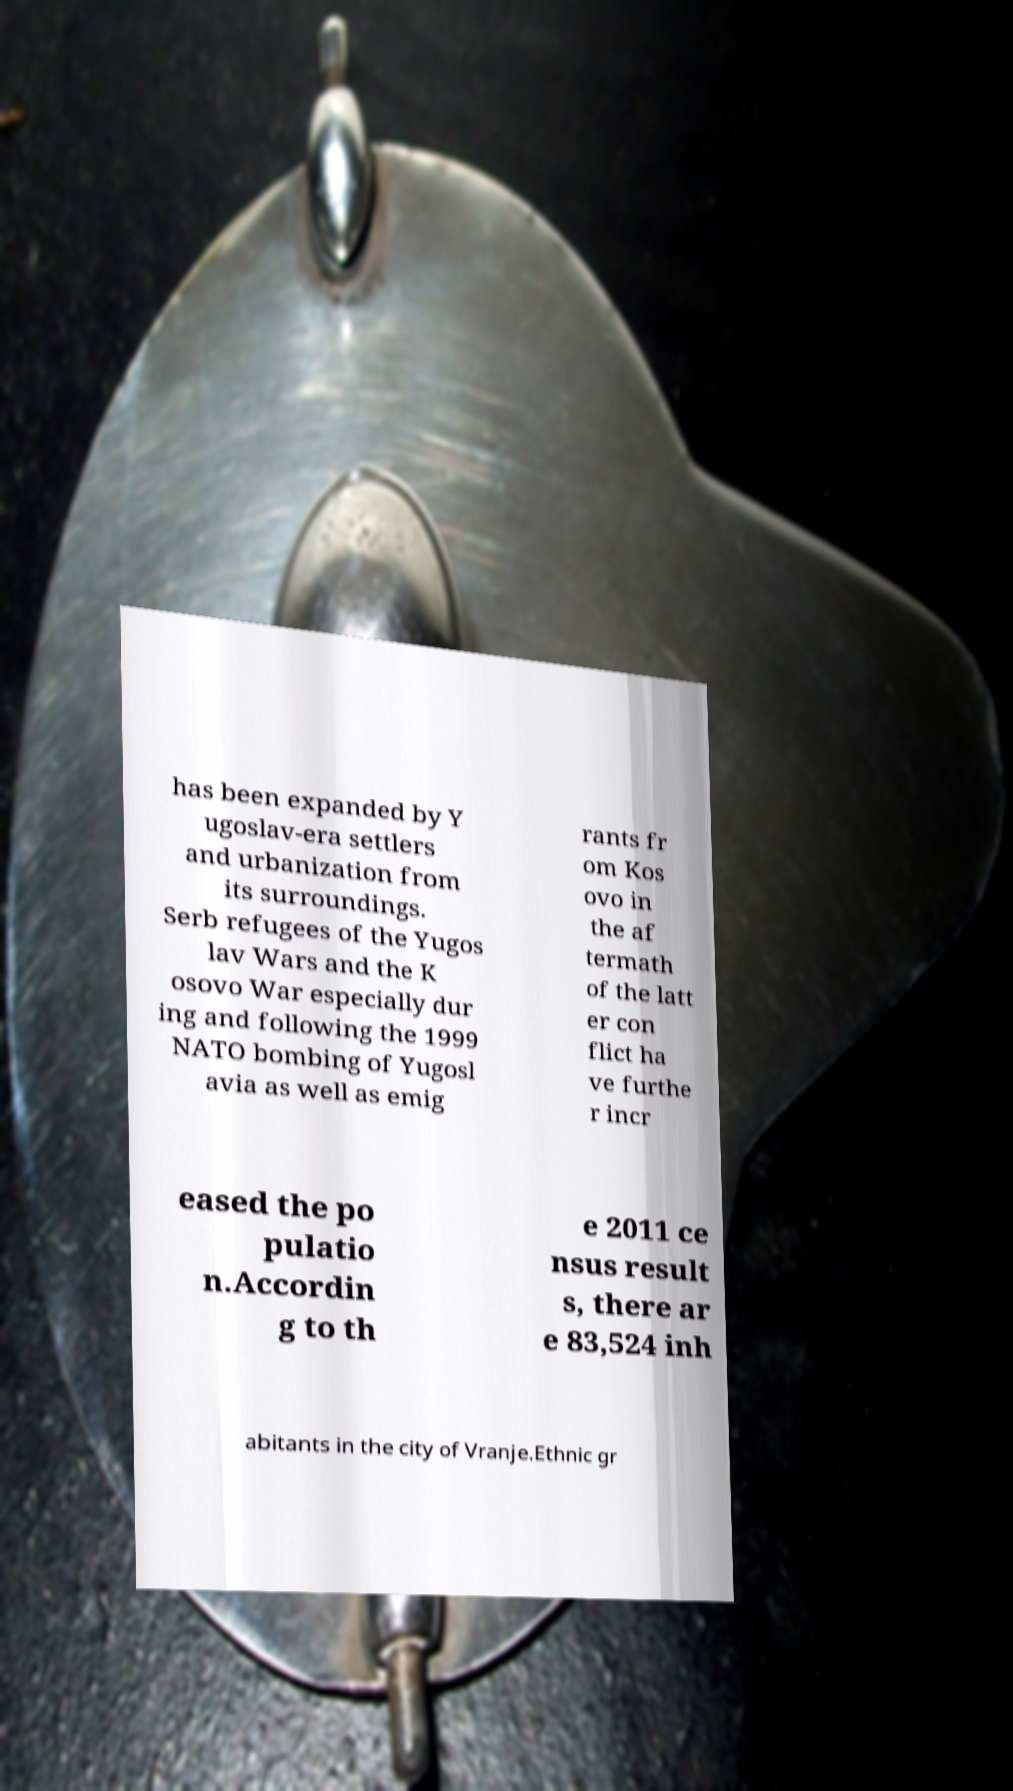What messages or text are displayed in this image? I need them in a readable, typed format. has been expanded by Y ugoslav-era settlers and urbanization from its surroundings. Serb refugees of the Yugos lav Wars and the K osovo War especially dur ing and following the 1999 NATO bombing of Yugosl avia as well as emig rants fr om Kos ovo in the af termath of the latt er con flict ha ve furthe r incr eased the po pulatio n.Accordin g to th e 2011 ce nsus result s, there ar e 83,524 inh abitants in the city of Vranje.Ethnic gr 